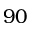Convert formula to latex. <formula><loc_0><loc_0><loc_500><loc_500>9 0</formula> 